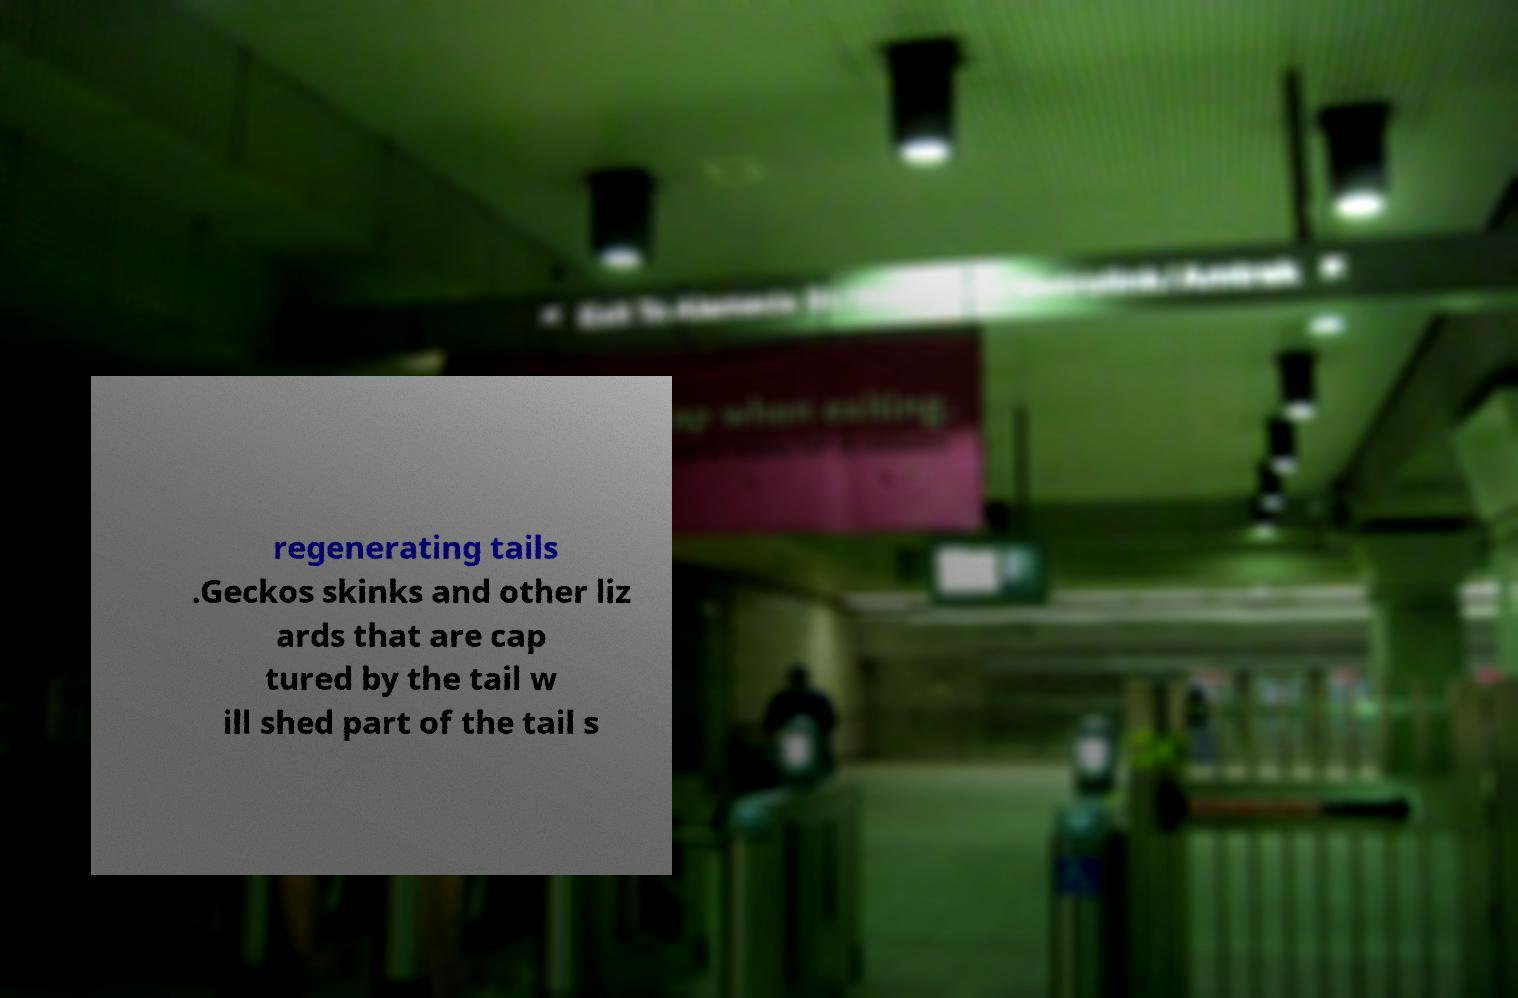There's text embedded in this image that I need extracted. Can you transcribe it verbatim? regenerating tails .Geckos skinks and other liz ards that are cap tured by the tail w ill shed part of the tail s 